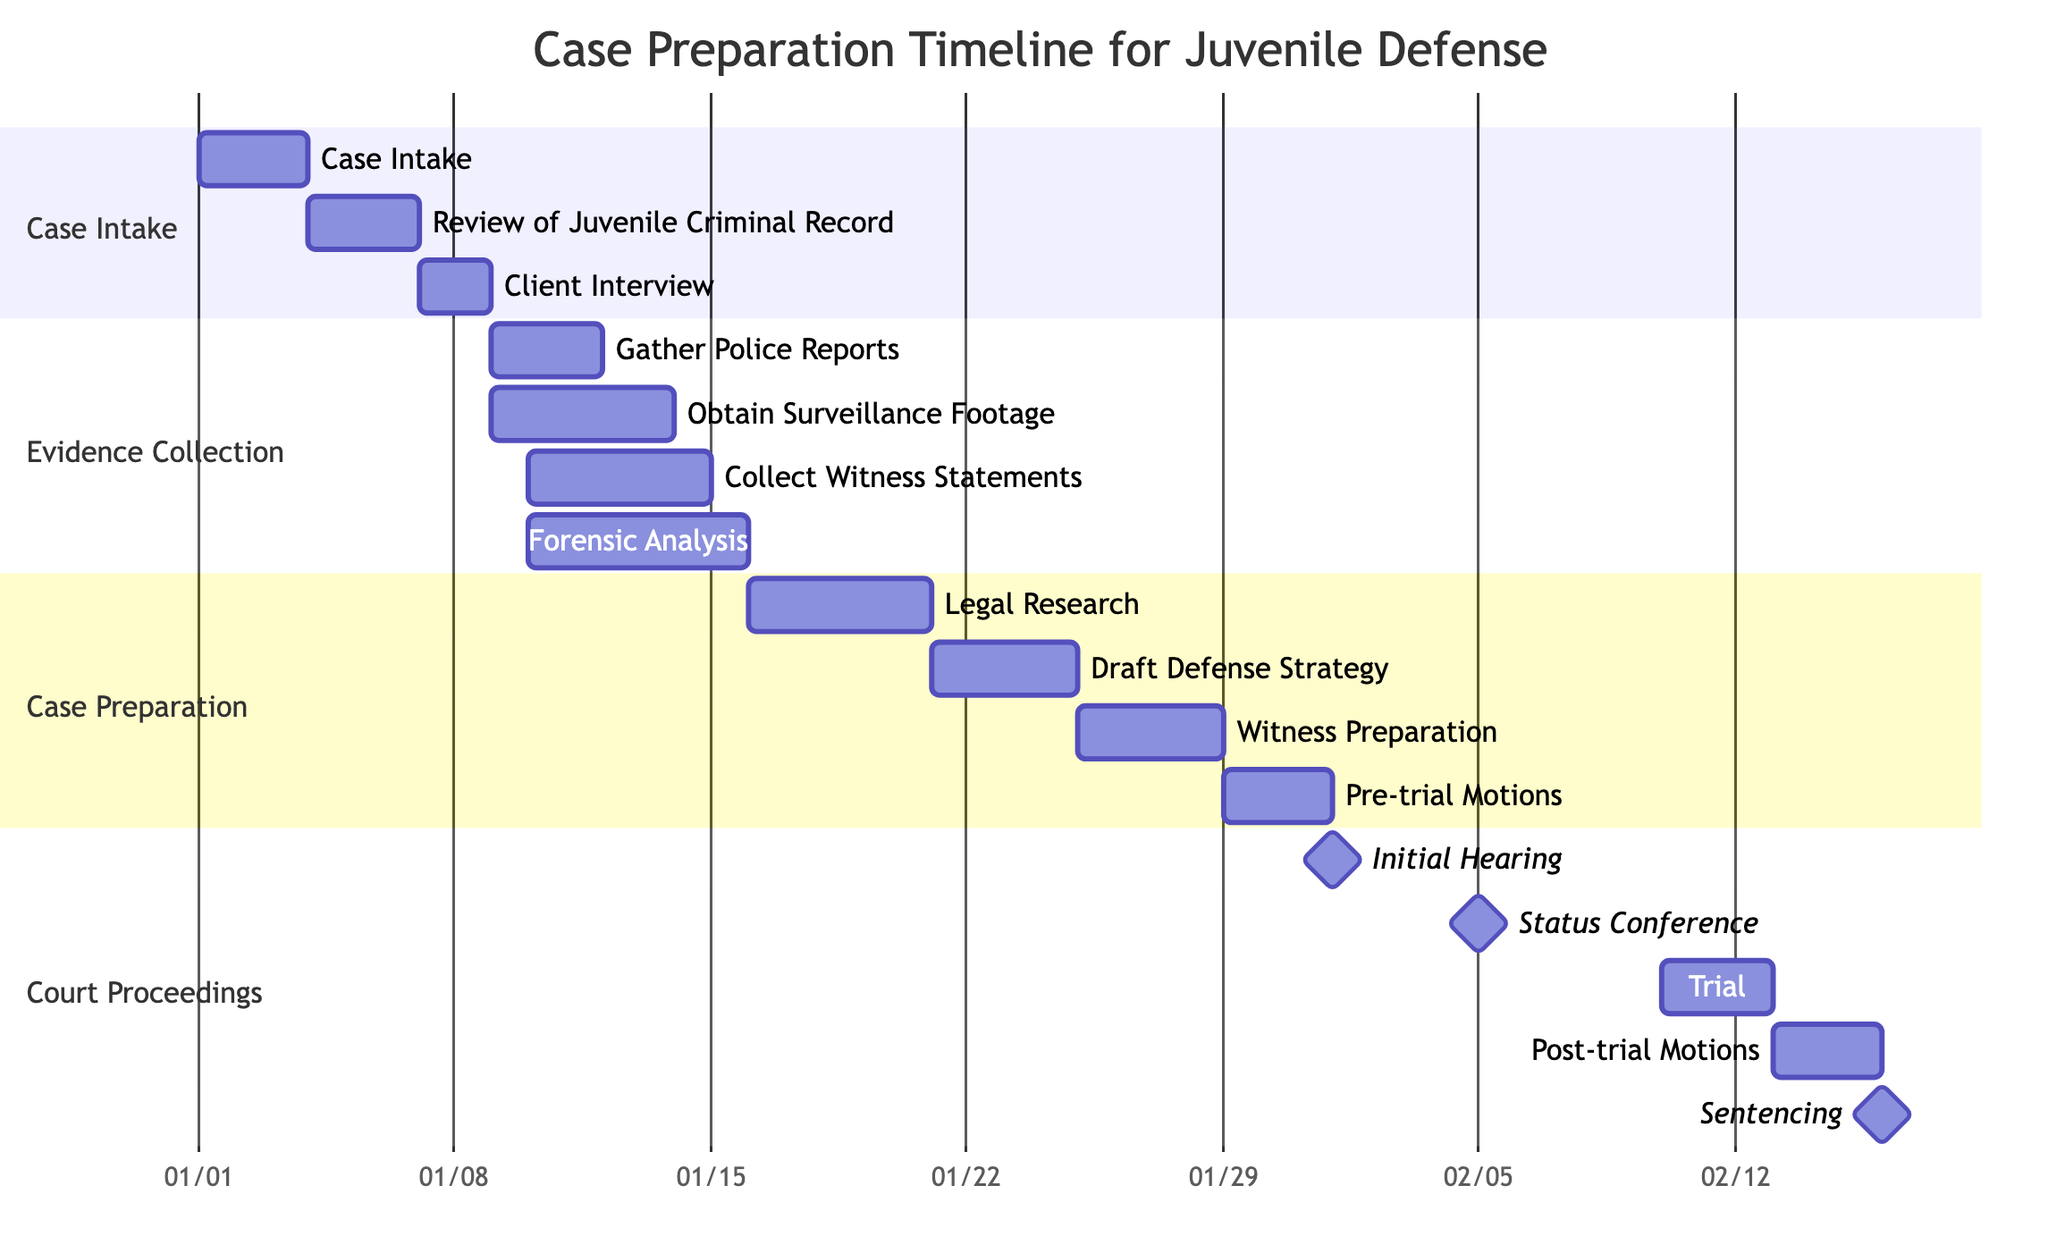What is the duration of the "Client Interview" task? The "Client Interview" task starts on January 7 and ends on January 8, so the duration is from the start date to the end date, which is 2 days.
Answer: 2 days Which task occurs after "Gather Police Reports"? "Gather Police Reports" tasks ends on January 11. The next task that starts after that is "Obtain Surveillance Footage," which begins on January 9 but overlaps. However, the most immediate following task in terms of completion is "Collect Witness Statements," starting on January 10.
Answer: Collect Witness Statements How many days does "Witness Preparation" last? The "Witness Preparation" task starts on January 25 and ends on January 28, which calculates to 4 days from start to finish.
Answer: 4 days What is the earliest court appearance in the timeline? The "Initial Hearing" is marked as a milestone and starts on February 1, which is the earliest court appearance in the timeline.
Answer: Initial Hearing How many total tasks are involved in evidence collection? There are four subtasks listed under "Evidence Collection," which includes: "Gather Police Reports," "Obtain Surveillance Footage," "Collect Witness Statements," and "Forensic Analysis." Counting these gives a total of four tasks.
Answer: 4 tasks Which task takes the longest duration in the evidence collection section? "Forensic Analysis" starts on January 10 and ends on January 15, lasting a total of 6 days, which is the longest duration in the evidence collection section. Other tasks do not exceed this duration.
Answer: Forensic Analysis What is the last milestone in the diagram? The last milestone in the diagram is "Sentencing," which is scheduled for February 16 and marks the final event in the court proceedings.
Answer: Sentencing How many days are between the "Trial" and "Sentencing"? The "Trial" ends on February 12, and "Sentencing" occurs on February 16, leaving 4 days between the two events.
Answer: 4 days What is the start date of the "Draft Defense Strategy" task? The "Draft Defense Strategy" task begins on January 21, as indicated in the timeline.
Answer: January 21 